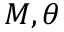<formula> <loc_0><loc_0><loc_500><loc_500>M , \theta</formula> 